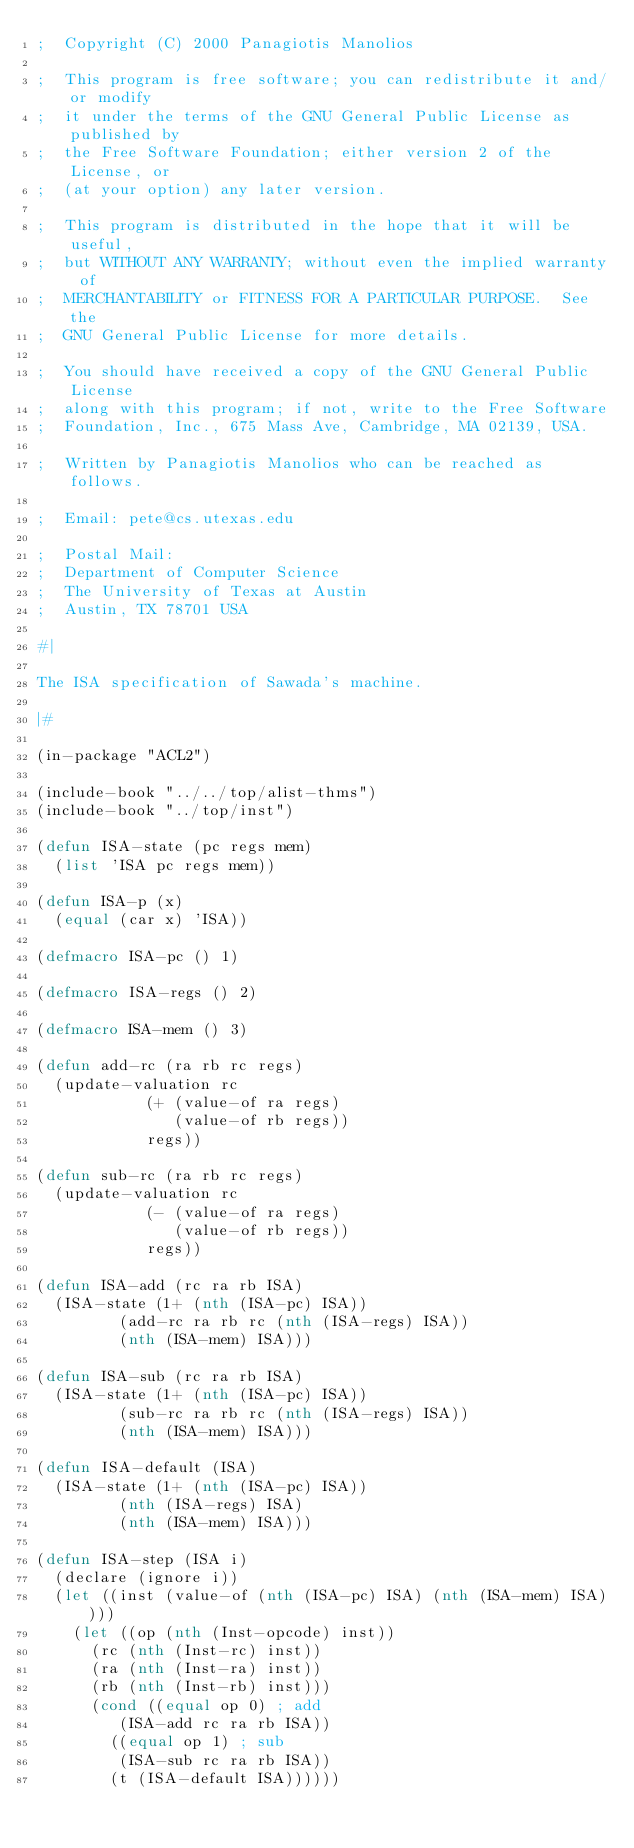<code> <loc_0><loc_0><loc_500><loc_500><_Lisp_>;  Copyright (C) 2000 Panagiotis Manolios

;  This program is free software; you can redistribute it and/or modify
;  it under the terms of the GNU General Public License as published by
;  the Free Software Foundation; either version 2 of the License, or
;  (at your option) any later version.

;  This program is distributed in the hope that it will be useful,
;  but WITHOUT ANY WARRANTY; without even the implied warranty of
;  MERCHANTABILITY or FITNESS FOR A PARTICULAR PURPOSE.  See the
;  GNU General Public License for more details.

;  You should have received a copy of the GNU General Public License
;  along with this program; if not, write to the Free Software
;  Foundation, Inc., 675 Mass Ave, Cambridge, MA 02139, USA.

;  Written by Panagiotis Manolios who can be reached as follows.

;  Email: pete@cs.utexas.edu

;  Postal Mail:
;  Department of Computer Science
;  The University of Texas at Austin
;  Austin, TX 78701 USA

#|

The ISA specification of Sawada's machine.

|#

(in-package "ACL2")

(include-book "../../top/alist-thms")
(include-book "../top/inst")

(defun ISA-state (pc regs mem)
  (list 'ISA pc regs mem))

(defun ISA-p (x)
  (equal (car x) 'ISA))

(defmacro ISA-pc () 1)

(defmacro ISA-regs () 2)

(defmacro ISA-mem () 3)

(defun add-rc (ra rb rc regs)
  (update-valuation rc
		    (+ (value-of ra regs)
		       (value-of rb regs))
		    regs))

(defun sub-rc (ra rb rc regs)
  (update-valuation rc
		    (- (value-of ra regs)
		       (value-of rb regs))
		    regs))

(defun ISA-add (rc ra rb ISA)
  (ISA-state (1+ (nth (ISA-pc) ISA))
	     (add-rc ra rb rc (nth (ISA-regs) ISA))
	     (nth (ISA-mem) ISA)))

(defun ISA-sub (rc ra rb ISA)
  (ISA-state (1+ (nth (ISA-pc) ISA))
	     (sub-rc ra rb rc (nth (ISA-regs) ISA))
	     (nth (ISA-mem) ISA)))

(defun ISA-default (ISA)
  (ISA-state (1+ (nth (ISA-pc) ISA))
	     (nth (ISA-regs) ISA)
	     (nth (ISA-mem) ISA)))

(defun ISA-step (ISA i)
  (declare (ignore i))
  (let ((inst (value-of (nth (ISA-pc) ISA) (nth (ISA-mem) ISA))))
    (let ((op (nth (Inst-opcode) inst))
	  (rc (nth (Inst-rc) inst))
	  (ra (nth (Inst-ra) inst))
	  (rb (nth (Inst-rb) inst)))
      (cond ((equal op 0) ; add
	     (ISA-add rc ra rb ISA))
	    ((equal op 1) ; sub
	     (ISA-sub rc ra rb ISA))
	    (t (ISA-default ISA))))))
</code> 